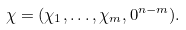Convert formula to latex. <formula><loc_0><loc_0><loc_500><loc_500>\chi = ( \chi _ { 1 } , \dots , \chi _ { m } , 0 ^ { n - m } ) .</formula> 